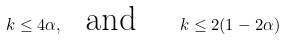<formula> <loc_0><loc_0><loc_500><loc_500>k \leq 4 \alpha , \text { \ and \quad } k \leq 2 ( 1 - 2 \alpha )</formula> 